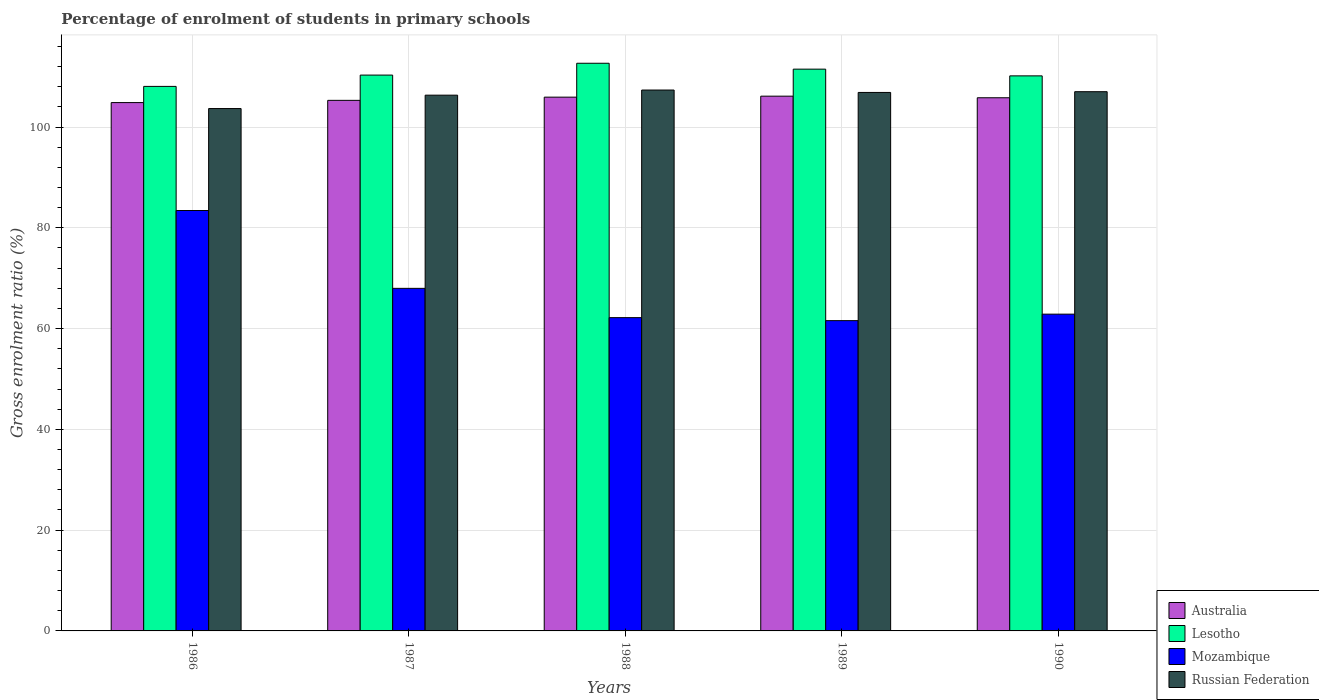How many different coloured bars are there?
Make the answer very short. 4. How many bars are there on the 2nd tick from the left?
Offer a very short reply. 4. How many bars are there on the 3rd tick from the right?
Ensure brevity in your answer.  4. What is the label of the 5th group of bars from the left?
Your answer should be compact. 1990. What is the percentage of students enrolled in primary schools in Australia in 1988?
Provide a succinct answer. 105.93. Across all years, what is the maximum percentage of students enrolled in primary schools in Mozambique?
Your answer should be very brief. 83.44. Across all years, what is the minimum percentage of students enrolled in primary schools in Australia?
Your answer should be very brief. 104.85. In which year was the percentage of students enrolled in primary schools in Lesotho maximum?
Keep it short and to the point. 1988. In which year was the percentage of students enrolled in primary schools in Russian Federation minimum?
Ensure brevity in your answer.  1986. What is the total percentage of students enrolled in primary schools in Mozambique in the graph?
Your answer should be very brief. 338.04. What is the difference between the percentage of students enrolled in primary schools in Mozambique in 1986 and that in 1987?
Your answer should be very brief. 15.45. What is the difference between the percentage of students enrolled in primary schools in Russian Federation in 1989 and the percentage of students enrolled in primary schools in Lesotho in 1990?
Your response must be concise. -3.29. What is the average percentage of students enrolled in primary schools in Russian Federation per year?
Provide a short and direct response. 106.24. In the year 1989, what is the difference between the percentage of students enrolled in primary schools in Australia and percentage of students enrolled in primary schools in Lesotho?
Provide a short and direct response. -5.36. What is the ratio of the percentage of students enrolled in primary schools in Russian Federation in 1988 to that in 1989?
Give a very brief answer. 1. Is the percentage of students enrolled in primary schools in Mozambique in 1987 less than that in 1988?
Ensure brevity in your answer.  No. Is the difference between the percentage of students enrolled in primary schools in Australia in 1988 and 1990 greater than the difference between the percentage of students enrolled in primary schools in Lesotho in 1988 and 1990?
Give a very brief answer. No. What is the difference between the highest and the second highest percentage of students enrolled in primary schools in Mozambique?
Provide a short and direct response. 15.45. What is the difference between the highest and the lowest percentage of students enrolled in primary schools in Russian Federation?
Give a very brief answer. 3.67. Is the sum of the percentage of students enrolled in primary schools in Lesotho in 1986 and 1989 greater than the maximum percentage of students enrolled in primary schools in Australia across all years?
Make the answer very short. Yes. What does the 2nd bar from the right in 1986 represents?
Your response must be concise. Mozambique. Is it the case that in every year, the sum of the percentage of students enrolled in primary schools in Lesotho and percentage of students enrolled in primary schools in Russian Federation is greater than the percentage of students enrolled in primary schools in Mozambique?
Ensure brevity in your answer.  Yes. How many bars are there?
Give a very brief answer. 20. What is the difference between two consecutive major ticks on the Y-axis?
Keep it short and to the point. 20. Are the values on the major ticks of Y-axis written in scientific E-notation?
Your response must be concise. No. Does the graph contain any zero values?
Offer a very short reply. No. What is the title of the graph?
Provide a short and direct response. Percentage of enrolment of students in primary schools. What is the Gross enrolment ratio (%) in Australia in 1986?
Give a very brief answer. 104.85. What is the Gross enrolment ratio (%) of Lesotho in 1986?
Your answer should be very brief. 108.07. What is the Gross enrolment ratio (%) of Mozambique in 1986?
Provide a succinct answer. 83.44. What is the Gross enrolment ratio (%) of Russian Federation in 1986?
Ensure brevity in your answer.  103.67. What is the Gross enrolment ratio (%) of Australia in 1987?
Offer a terse response. 105.3. What is the Gross enrolment ratio (%) of Lesotho in 1987?
Provide a succinct answer. 110.31. What is the Gross enrolment ratio (%) of Mozambique in 1987?
Offer a very short reply. 67.99. What is the Gross enrolment ratio (%) in Russian Federation in 1987?
Keep it short and to the point. 106.32. What is the Gross enrolment ratio (%) of Australia in 1988?
Keep it short and to the point. 105.93. What is the Gross enrolment ratio (%) in Lesotho in 1988?
Your answer should be very brief. 112.66. What is the Gross enrolment ratio (%) in Mozambique in 1988?
Your response must be concise. 62.18. What is the Gross enrolment ratio (%) in Russian Federation in 1988?
Give a very brief answer. 107.34. What is the Gross enrolment ratio (%) in Australia in 1989?
Keep it short and to the point. 106.13. What is the Gross enrolment ratio (%) in Lesotho in 1989?
Offer a very short reply. 111.49. What is the Gross enrolment ratio (%) in Mozambique in 1989?
Offer a terse response. 61.58. What is the Gross enrolment ratio (%) of Russian Federation in 1989?
Give a very brief answer. 106.87. What is the Gross enrolment ratio (%) in Australia in 1990?
Your response must be concise. 105.81. What is the Gross enrolment ratio (%) of Lesotho in 1990?
Provide a succinct answer. 110.15. What is the Gross enrolment ratio (%) of Mozambique in 1990?
Your answer should be compact. 62.87. What is the Gross enrolment ratio (%) of Russian Federation in 1990?
Ensure brevity in your answer.  107.01. Across all years, what is the maximum Gross enrolment ratio (%) in Australia?
Provide a succinct answer. 106.13. Across all years, what is the maximum Gross enrolment ratio (%) of Lesotho?
Make the answer very short. 112.66. Across all years, what is the maximum Gross enrolment ratio (%) in Mozambique?
Offer a terse response. 83.44. Across all years, what is the maximum Gross enrolment ratio (%) of Russian Federation?
Provide a short and direct response. 107.34. Across all years, what is the minimum Gross enrolment ratio (%) of Australia?
Keep it short and to the point. 104.85. Across all years, what is the minimum Gross enrolment ratio (%) of Lesotho?
Your response must be concise. 108.07. Across all years, what is the minimum Gross enrolment ratio (%) of Mozambique?
Provide a short and direct response. 61.58. Across all years, what is the minimum Gross enrolment ratio (%) of Russian Federation?
Ensure brevity in your answer.  103.67. What is the total Gross enrolment ratio (%) of Australia in the graph?
Offer a very short reply. 528.02. What is the total Gross enrolment ratio (%) in Lesotho in the graph?
Give a very brief answer. 552.68. What is the total Gross enrolment ratio (%) in Mozambique in the graph?
Your response must be concise. 338.04. What is the total Gross enrolment ratio (%) in Russian Federation in the graph?
Your answer should be very brief. 531.22. What is the difference between the Gross enrolment ratio (%) of Australia in 1986 and that in 1987?
Ensure brevity in your answer.  -0.44. What is the difference between the Gross enrolment ratio (%) in Lesotho in 1986 and that in 1987?
Give a very brief answer. -2.24. What is the difference between the Gross enrolment ratio (%) in Mozambique in 1986 and that in 1987?
Give a very brief answer. 15.45. What is the difference between the Gross enrolment ratio (%) of Russian Federation in 1986 and that in 1987?
Make the answer very short. -2.65. What is the difference between the Gross enrolment ratio (%) of Australia in 1986 and that in 1988?
Give a very brief answer. -1.08. What is the difference between the Gross enrolment ratio (%) in Lesotho in 1986 and that in 1988?
Make the answer very short. -4.59. What is the difference between the Gross enrolment ratio (%) of Mozambique in 1986 and that in 1988?
Keep it short and to the point. 21.26. What is the difference between the Gross enrolment ratio (%) in Russian Federation in 1986 and that in 1988?
Keep it short and to the point. -3.67. What is the difference between the Gross enrolment ratio (%) of Australia in 1986 and that in 1989?
Make the answer very short. -1.27. What is the difference between the Gross enrolment ratio (%) of Lesotho in 1986 and that in 1989?
Keep it short and to the point. -3.42. What is the difference between the Gross enrolment ratio (%) in Mozambique in 1986 and that in 1989?
Your response must be concise. 21.86. What is the difference between the Gross enrolment ratio (%) in Russian Federation in 1986 and that in 1989?
Give a very brief answer. -3.2. What is the difference between the Gross enrolment ratio (%) in Australia in 1986 and that in 1990?
Offer a very short reply. -0.96. What is the difference between the Gross enrolment ratio (%) of Lesotho in 1986 and that in 1990?
Ensure brevity in your answer.  -2.09. What is the difference between the Gross enrolment ratio (%) in Mozambique in 1986 and that in 1990?
Make the answer very short. 20.57. What is the difference between the Gross enrolment ratio (%) of Russian Federation in 1986 and that in 1990?
Your answer should be very brief. -3.34. What is the difference between the Gross enrolment ratio (%) of Australia in 1987 and that in 1988?
Your answer should be very brief. -0.64. What is the difference between the Gross enrolment ratio (%) of Lesotho in 1987 and that in 1988?
Offer a terse response. -2.35. What is the difference between the Gross enrolment ratio (%) in Mozambique in 1987 and that in 1988?
Ensure brevity in your answer.  5.81. What is the difference between the Gross enrolment ratio (%) in Russian Federation in 1987 and that in 1988?
Your answer should be compact. -1.02. What is the difference between the Gross enrolment ratio (%) in Australia in 1987 and that in 1989?
Your answer should be very brief. -0.83. What is the difference between the Gross enrolment ratio (%) of Lesotho in 1987 and that in 1989?
Provide a short and direct response. -1.18. What is the difference between the Gross enrolment ratio (%) of Mozambique in 1987 and that in 1989?
Your answer should be compact. 6.41. What is the difference between the Gross enrolment ratio (%) of Russian Federation in 1987 and that in 1989?
Your response must be concise. -0.54. What is the difference between the Gross enrolment ratio (%) in Australia in 1987 and that in 1990?
Make the answer very short. -0.51. What is the difference between the Gross enrolment ratio (%) of Lesotho in 1987 and that in 1990?
Give a very brief answer. 0.16. What is the difference between the Gross enrolment ratio (%) of Mozambique in 1987 and that in 1990?
Ensure brevity in your answer.  5.12. What is the difference between the Gross enrolment ratio (%) in Russian Federation in 1987 and that in 1990?
Provide a short and direct response. -0.69. What is the difference between the Gross enrolment ratio (%) of Australia in 1988 and that in 1989?
Your answer should be very brief. -0.19. What is the difference between the Gross enrolment ratio (%) in Lesotho in 1988 and that in 1989?
Your answer should be compact. 1.17. What is the difference between the Gross enrolment ratio (%) of Mozambique in 1988 and that in 1989?
Provide a succinct answer. 0.6. What is the difference between the Gross enrolment ratio (%) in Russian Federation in 1988 and that in 1989?
Make the answer very short. 0.48. What is the difference between the Gross enrolment ratio (%) of Australia in 1988 and that in 1990?
Give a very brief answer. 0.12. What is the difference between the Gross enrolment ratio (%) in Lesotho in 1988 and that in 1990?
Give a very brief answer. 2.5. What is the difference between the Gross enrolment ratio (%) in Mozambique in 1988 and that in 1990?
Make the answer very short. -0.69. What is the difference between the Gross enrolment ratio (%) of Russian Federation in 1988 and that in 1990?
Your response must be concise. 0.33. What is the difference between the Gross enrolment ratio (%) of Australia in 1989 and that in 1990?
Give a very brief answer. 0.32. What is the difference between the Gross enrolment ratio (%) of Lesotho in 1989 and that in 1990?
Provide a succinct answer. 1.34. What is the difference between the Gross enrolment ratio (%) of Mozambique in 1989 and that in 1990?
Make the answer very short. -1.29. What is the difference between the Gross enrolment ratio (%) in Russian Federation in 1989 and that in 1990?
Your response must be concise. -0.15. What is the difference between the Gross enrolment ratio (%) in Australia in 1986 and the Gross enrolment ratio (%) in Lesotho in 1987?
Keep it short and to the point. -5.46. What is the difference between the Gross enrolment ratio (%) of Australia in 1986 and the Gross enrolment ratio (%) of Mozambique in 1987?
Offer a terse response. 36.87. What is the difference between the Gross enrolment ratio (%) of Australia in 1986 and the Gross enrolment ratio (%) of Russian Federation in 1987?
Provide a succinct answer. -1.47. What is the difference between the Gross enrolment ratio (%) in Lesotho in 1986 and the Gross enrolment ratio (%) in Mozambique in 1987?
Your response must be concise. 40.08. What is the difference between the Gross enrolment ratio (%) of Lesotho in 1986 and the Gross enrolment ratio (%) of Russian Federation in 1987?
Keep it short and to the point. 1.74. What is the difference between the Gross enrolment ratio (%) in Mozambique in 1986 and the Gross enrolment ratio (%) in Russian Federation in 1987?
Ensure brevity in your answer.  -22.89. What is the difference between the Gross enrolment ratio (%) in Australia in 1986 and the Gross enrolment ratio (%) in Lesotho in 1988?
Ensure brevity in your answer.  -7.8. What is the difference between the Gross enrolment ratio (%) in Australia in 1986 and the Gross enrolment ratio (%) in Mozambique in 1988?
Keep it short and to the point. 42.68. What is the difference between the Gross enrolment ratio (%) of Australia in 1986 and the Gross enrolment ratio (%) of Russian Federation in 1988?
Your answer should be compact. -2.49. What is the difference between the Gross enrolment ratio (%) in Lesotho in 1986 and the Gross enrolment ratio (%) in Mozambique in 1988?
Provide a short and direct response. 45.89. What is the difference between the Gross enrolment ratio (%) of Lesotho in 1986 and the Gross enrolment ratio (%) of Russian Federation in 1988?
Ensure brevity in your answer.  0.72. What is the difference between the Gross enrolment ratio (%) in Mozambique in 1986 and the Gross enrolment ratio (%) in Russian Federation in 1988?
Ensure brevity in your answer.  -23.91. What is the difference between the Gross enrolment ratio (%) in Australia in 1986 and the Gross enrolment ratio (%) in Lesotho in 1989?
Your response must be concise. -6.64. What is the difference between the Gross enrolment ratio (%) of Australia in 1986 and the Gross enrolment ratio (%) of Mozambique in 1989?
Offer a very short reply. 43.28. What is the difference between the Gross enrolment ratio (%) in Australia in 1986 and the Gross enrolment ratio (%) in Russian Federation in 1989?
Offer a terse response. -2.01. What is the difference between the Gross enrolment ratio (%) in Lesotho in 1986 and the Gross enrolment ratio (%) in Mozambique in 1989?
Give a very brief answer. 46.49. What is the difference between the Gross enrolment ratio (%) in Lesotho in 1986 and the Gross enrolment ratio (%) in Russian Federation in 1989?
Offer a very short reply. 1.2. What is the difference between the Gross enrolment ratio (%) in Mozambique in 1986 and the Gross enrolment ratio (%) in Russian Federation in 1989?
Your response must be concise. -23.43. What is the difference between the Gross enrolment ratio (%) of Australia in 1986 and the Gross enrolment ratio (%) of Lesotho in 1990?
Keep it short and to the point. -5.3. What is the difference between the Gross enrolment ratio (%) in Australia in 1986 and the Gross enrolment ratio (%) in Mozambique in 1990?
Your response must be concise. 41.99. What is the difference between the Gross enrolment ratio (%) of Australia in 1986 and the Gross enrolment ratio (%) of Russian Federation in 1990?
Ensure brevity in your answer.  -2.16. What is the difference between the Gross enrolment ratio (%) of Lesotho in 1986 and the Gross enrolment ratio (%) of Mozambique in 1990?
Your response must be concise. 45.2. What is the difference between the Gross enrolment ratio (%) of Lesotho in 1986 and the Gross enrolment ratio (%) of Russian Federation in 1990?
Your answer should be very brief. 1.05. What is the difference between the Gross enrolment ratio (%) in Mozambique in 1986 and the Gross enrolment ratio (%) in Russian Federation in 1990?
Ensure brevity in your answer.  -23.58. What is the difference between the Gross enrolment ratio (%) of Australia in 1987 and the Gross enrolment ratio (%) of Lesotho in 1988?
Provide a short and direct response. -7.36. What is the difference between the Gross enrolment ratio (%) of Australia in 1987 and the Gross enrolment ratio (%) of Mozambique in 1988?
Offer a terse response. 43.12. What is the difference between the Gross enrolment ratio (%) in Australia in 1987 and the Gross enrolment ratio (%) in Russian Federation in 1988?
Keep it short and to the point. -2.05. What is the difference between the Gross enrolment ratio (%) in Lesotho in 1987 and the Gross enrolment ratio (%) in Mozambique in 1988?
Provide a succinct answer. 48.13. What is the difference between the Gross enrolment ratio (%) of Lesotho in 1987 and the Gross enrolment ratio (%) of Russian Federation in 1988?
Your answer should be very brief. 2.96. What is the difference between the Gross enrolment ratio (%) of Mozambique in 1987 and the Gross enrolment ratio (%) of Russian Federation in 1988?
Offer a terse response. -39.36. What is the difference between the Gross enrolment ratio (%) in Australia in 1987 and the Gross enrolment ratio (%) in Lesotho in 1989?
Provide a short and direct response. -6.19. What is the difference between the Gross enrolment ratio (%) of Australia in 1987 and the Gross enrolment ratio (%) of Mozambique in 1989?
Your answer should be compact. 43.72. What is the difference between the Gross enrolment ratio (%) in Australia in 1987 and the Gross enrolment ratio (%) in Russian Federation in 1989?
Offer a terse response. -1.57. What is the difference between the Gross enrolment ratio (%) in Lesotho in 1987 and the Gross enrolment ratio (%) in Mozambique in 1989?
Provide a short and direct response. 48.73. What is the difference between the Gross enrolment ratio (%) of Lesotho in 1987 and the Gross enrolment ratio (%) of Russian Federation in 1989?
Keep it short and to the point. 3.44. What is the difference between the Gross enrolment ratio (%) in Mozambique in 1987 and the Gross enrolment ratio (%) in Russian Federation in 1989?
Your answer should be compact. -38.88. What is the difference between the Gross enrolment ratio (%) of Australia in 1987 and the Gross enrolment ratio (%) of Lesotho in 1990?
Provide a succinct answer. -4.86. What is the difference between the Gross enrolment ratio (%) in Australia in 1987 and the Gross enrolment ratio (%) in Mozambique in 1990?
Your answer should be compact. 42.43. What is the difference between the Gross enrolment ratio (%) of Australia in 1987 and the Gross enrolment ratio (%) of Russian Federation in 1990?
Offer a terse response. -1.72. What is the difference between the Gross enrolment ratio (%) in Lesotho in 1987 and the Gross enrolment ratio (%) in Mozambique in 1990?
Offer a very short reply. 47.44. What is the difference between the Gross enrolment ratio (%) of Lesotho in 1987 and the Gross enrolment ratio (%) of Russian Federation in 1990?
Give a very brief answer. 3.3. What is the difference between the Gross enrolment ratio (%) in Mozambique in 1987 and the Gross enrolment ratio (%) in Russian Federation in 1990?
Ensure brevity in your answer.  -39.03. What is the difference between the Gross enrolment ratio (%) of Australia in 1988 and the Gross enrolment ratio (%) of Lesotho in 1989?
Give a very brief answer. -5.56. What is the difference between the Gross enrolment ratio (%) in Australia in 1988 and the Gross enrolment ratio (%) in Mozambique in 1989?
Offer a terse response. 44.35. What is the difference between the Gross enrolment ratio (%) in Australia in 1988 and the Gross enrolment ratio (%) in Russian Federation in 1989?
Offer a very short reply. -0.93. What is the difference between the Gross enrolment ratio (%) in Lesotho in 1988 and the Gross enrolment ratio (%) in Mozambique in 1989?
Provide a succinct answer. 51.08. What is the difference between the Gross enrolment ratio (%) in Lesotho in 1988 and the Gross enrolment ratio (%) in Russian Federation in 1989?
Your answer should be compact. 5.79. What is the difference between the Gross enrolment ratio (%) of Mozambique in 1988 and the Gross enrolment ratio (%) of Russian Federation in 1989?
Your answer should be very brief. -44.69. What is the difference between the Gross enrolment ratio (%) in Australia in 1988 and the Gross enrolment ratio (%) in Lesotho in 1990?
Make the answer very short. -4.22. What is the difference between the Gross enrolment ratio (%) in Australia in 1988 and the Gross enrolment ratio (%) in Mozambique in 1990?
Ensure brevity in your answer.  43.07. What is the difference between the Gross enrolment ratio (%) in Australia in 1988 and the Gross enrolment ratio (%) in Russian Federation in 1990?
Your answer should be compact. -1.08. What is the difference between the Gross enrolment ratio (%) of Lesotho in 1988 and the Gross enrolment ratio (%) of Mozambique in 1990?
Provide a succinct answer. 49.79. What is the difference between the Gross enrolment ratio (%) of Lesotho in 1988 and the Gross enrolment ratio (%) of Russian Federation in 1990?
Provide a short and direct response. 5.64. What is the difference between the Gross enrolment ratio (%) in Mozambique in 1988 and the Gross enrolment ratio (%) in Russian Federation in 1990?
Your answer should be very brief. -44.84. What is the difference between the Gross enrolment ratio (%) in Australia in 1989 and the Gross enrolment ratio (%) in Lesotho in 1990?
Provide a short and direct response. -4.03. What is the difference between the Gross enrolment ratio (%) of Australia in 1989 and the Gross enrolment ratio (%) of Mozambique in 1990?
Your response must be concise. 43.26. What is the difference between the Gross enrolment ratio (%) in Australia in 1989 and the Gross enrolment ratio (%) in Russian Federation in 1990?
Provide a short and direct response. -0.89. What is the difference between the Gross enrolment ratio (%) of Lesotho in 1989 and the Gross enrolment ratio (%) of Mozambique in 1990?
Ensure brevity in your answer.  48.62. What is the difference between the Gross enrolment ratio (%) of Lesotho in 1989 and the Gross enrolment ratio (%) of Russian Federation in 1990?
Your answer should be compact. 4.48. What is the difference between the Gross enrolment ratio (%) in Mozambique in 1989 and the Gross enrolment ratio (%) in Russian Federation in 1990?
Your response must be concise. -45.44. What is the average Gross enrolment ratio (%) of Australia per year?
Your answer should be very brief. 105.6. What is the average Gross enrolment ratio (%) in Lesotho per year?
Make the answer very short. 110.54. What is the average Gross enrolment ratio (%) in Mozambique per year?
Keep it short and to the point. 67.61. What is the average Gross enrolment ratio (%) of Russian Federation per year?
Ensure brevity in your answer.  106.24. In the year 1986, what is the difference between the Gross enrolment ratio (%) in Australia and Gross enrolment ratio (%) in Lesotho?
Provide a succinct answer. -3.21. In the year 1986, what is the difference between the Gross enrolment ratio (%) in Australia and Gross enrolment ratio (%) in Mozambique?
Your answer should be compact. 21.42. In the year 1986, what is the difference between the Gross enrolment ratio (%) of Australia and Gross enrolment ratio (%) of Russian Federation?
Your response must be concise. 1.18. In the year 1986, what is the difference between the Gross enrolment ratio (%) of Lesotho and Gross enrolment ratio (%) of Mozambique?
Give a very brief answer. 24.63. In the year 1986, what is the difference between the Gross enrolment ratio (%) of Lesotho and Gross enrolment ratio (%) of Russian Federation?
Offer a terse response. 4.4. In the year 1986, what is the difference between the Gross enrolment ratio (%) in Mozambique and Gross enrolment ratio (%) in Russian Federation?
Give a very brief answer. -20.23. In the year 1987, what is the difference between the Gross enrolment ratio (%) of Australia and Gross enrolment ratio (%) of Lesotho?
Provide a short and direct response. -5.01. In the year 1987, what is the difference between the Gross enrolment ratio (%) in Australia and Gross enrolment ratio (%) in Mozambique?
Your answer should be very brief. 37.31. In the year 1987, what is the difference between the Gross enrolment ratio (%) of Australia and Gross enrolment ratio (%) of Russian Federation?
Make the answer very short. -1.03. In the year 1987, what is the difference between the Gross enrolment ratio (%) in Lesotho and Gross enrolment ratio (%) in Mozambique?
Offer a very short reply. 42.32. In the year 1987, what is the difference between the Gross enrolment ratio (%) in Lesotho and Gross enrolment ratio (%) in Russian Federation?
Provide a short and direct response. 3.98. In the year 1987, what is the difference between the Gross enrolment ratio (%) in Mozambique and Gross enrolment ratio (%) in Russian Federation?
Provide a succinct answer. -38.34. In the year 1988, what is the difference between the Gross enrolment ratio (%) of Australia and Gross enrolment ratio (%) of Lesotho?
Provide a short and direct response. -6.72. In the year 1988, what is the difference between the Gross enrolment ratio (%) of Australia and Gross enrolment ratio (%) of Mozambique?
Ensure brevity in your answer.  43.76. In the year 1988, what is the difference between the Gross enrolment ratio (%) in Australia and Gross enrolment ratio (%) in Russian Federation?
Make the answer very short. -1.41. In the year 1988, what is the difference between the Gross enrolment ratio (%) of Lesotho and Gross enrolment ratio (%) of Mozambique?
Your response must be concise. 50.48. In the year 1988, what is the difference between the Gross enrolment ratio (%) in Lesotho and Gross enrolment ratio (%) in Russian Federation?
Ensure brevity in your answer.  5.31. In the year 1988, what is the difference between the Gross enrolment ratio (%) in Mozambique and Gross enrolment ratio (%) in Russian Federation?
Ensure brevity in your answer.  -45.17. In the year 1989, what is the difference between the Gross enrolment ratio (%) of Australia and Gross enrolment ratio (%) of Lesotho?
Your response must be concise. -5.36. In the year 1989, what is the difference between the Gross enrolment ratio (%) in Australia and Gross enrolment ratio (%) in Mozambique?
Offer a terse response. 44.55. In the year 1989, what is the difference between the Gross enrolment ratio (%) of Australia and Gross enrolment ratio (%) of Russian Federation?
Give a very brief answer. -0.74. In the year 1989, what is the difference between the Gross enrolment ratio (%) of Lesotho and Gross enrolment ratio (%) of Mozambique?
Keep it short and to the point. 49.91. In the year 1989, what is the difference between the Gross enrolment ratio (%) of Lesotho and Gross enrolment ratio (%) of Russian Federation?
Offer a very short reply. 4.62. In the year 1989, what is the difference between the Gross enrolment ratio (%) of Mozambique and Gross enrolment ratio (%) of Russian Federation?
Provide a short and direct response. -45.29. In the year 1990, what is the difference between the Gross enrolment ratio (%) in Australia and Gross enrolment ratio (%) in Lesotho?
Your response must be concise. -4.34. In the year 1990, what is the difference between the Gross enrolment ratio (%) of Australia and Gross enrolment ratio (%) of Mozambique?
Keep it short and to the point. 42.94. In the year 1990, what is the difference between the Gross enrolment ratio (%) in Australia and Gross enrolment ratio (%) in Russian Federation?
Give a very brief answer. -1.2. In the year 1990, what is the difference between the Gross enrolment ratio (%) in Lesotho and Gross enrolment ratio (%) in Mozambique?
Keep it short and to the point. 47.29. In the year 1990, what is the difference between the Gross enrolment ratio (%) in Lesotho and Gross enrolment ratio (%) in Russian Federation?
Offer a very short reply. 3.14. In the year 1990, what is the difference between the Gross enrolment ratio (%) in Mozambique and Gross enrolment ratio (%) in Russian Federation?
Give a very brief answer. -44.15. What is the ratio of the Gross enrolment ratio (%) of Lesotho in 1986 to that in 1987?
Ensure brevity in your answer.  0.98. What is the ratio of the Gross enrolment ratio (%) in Mozambique in 1986 to that in 1987?
Offer a very short reply. 1.23. What is the ratio of the Gross enrolment ratio (%) in Russian Federation in 1986 to that in 1987?
Your answer should be very brief. 0.97. What is the ratio of the Gross enrolment ratio (%) of Lesotho in 1986 to that in 1988?
Your answer should be compact. 0.96. What is the ratio of the Gross enrolment ratio (%) of Mozambique in 1986 to that in 1988?
Make the answer very short. 1.34. What is the ratio of the Gross enrolment ratio (%) of Russian Federation in 1986 to that in 1988?
Give a very brief answer. 0.97. What is the ratio of the Gross enrolment ratio (%) in Australia in 1986 to that in 1989?
Your answer should be compact. 0.99. What is the ratio of the Gross enrolment ratio (%) of Lesotho in 1986 to that in 1989?
Ensure brevity in your answer.  0.97. What is the ratio of the Gross enrolment ratio (%) in Mozambique in 1986 to that in 1989?
Offer a terse response. 1.35. What is the ratio of the Gross enrolment ratio (%) of Russian Federation in 1986 to that in 1989?
Your answer should be compact. 0.97. What is the ratio of the Gross enrolment ratio (%) of Australia in 1986 to that in 1990?
Provide a short and direct response. 0.99. What is the ratio of the Gross enrolment ratio (%) of Mozambique in 1986 to that in 1990?
Your answer should be very brief. 1.33. What is the ratio of the Gross enrolment ratio (%) in Russian Federation in 1986 to that in 1990?
Give a very brief answer. 0.97. What is the ratio of the Gross enrolment ratio (%) in Australia in 1987 to that in 1988?
Provide a short and direct response. 0.99. What is the ratio of the Gross enrolment ratio (%) in Lesotho in 1987 to that in 1988?
Offer a terse response. 0.98. What is the ratio of the Gross enrolment ratio (%) of Mozambique in 1987 to that in 1988?
Your response must be concise. 1.09. What is the ratio of the Gross enrolment ratio (%) of Russian Federation in 1987 to that in 1988?
Give a very brief answer. 0.99. What is the ratio of the Gross enrolment ratio (%) in Australia in 1987 to that in 1989?
Provide a short and direct response. 0.99. What is the ratio of the Gross enrolment ratio (%) of Lesotho in 1987 to that in 1989?
Keep it short and to the point. 0.99. What is the ratio of the Gross enrolment ratio (%) of Mozambique in 1987 to that in 1989?
Your answer should be very brief. 1.1. What is the ratio of the Gross enrolment ratio (%) of Lesotho in 1987 to that in 1990?
Provide a succinct answer. 1. What is the ratio of the Gross enrolment ratio (%) in Mozambique in 1987 to that in 1990?
Give a very brief answer. 1.08. What is the ratio of the Gross enrolment ratio (%) of Australia in 1988 to that in 1989?
Your response must be concise. 1. What is the ratio of the Gross enrolment ratio (%) in Lesotho in 1988 to that in 1989?
Your answer should be very brief. 1.01. What is the ratio of the Gross enrolment ratio (%) of Mozambique in 1988 to that in 1989?
Provide a succinct answer. 1.01. What is the ratio of the Gross enrolment ratio (%) in Lesotho in 1988 to that in 1990?
Your answer should be compact. 1.02. What is the ratio of the Gross enrolment ratio (%) of Mozambique in 1988 to that in 1990?
Offer a terse response. 0.99. What is the ratio of the Gross enrolment ratio (%) of Russian Federation in 1988 to that in 1990?
Your answer should be very brief. 1. What is the ratio of the Gross enrolment ratio (%) of Lesotho in 1989 to that in 1990?
Provide a short and direct response. 1.01. What is the ratio of the Gross enrolment ratio (%) in Mozambique in 1989 to that in 1990?
Your answer should be compact. 0.98. What is the ratio of the Gross enrolment ratio (%) in Russian Federation in 1989 to that in 1990?
Ensure brevity in your answer.  1. What is the difference between the highest and the second highest Gross enrolment ratio (%) of Australia?
Your answer should be very brief. 0.19. What is the difference between the highest and the second highest Gross enrolment ratio (%) of Lesotho?
Ensure brevity in your answer.  1.17. What is the difference between the highest and the second highest Gross enrolment ratio (%) of Mozambique?
Make the answer very short. 15.45. What is the difference between the highest and the second highest Gross enrolment ratio (%) of Russian Federation?
Your answer should be very brief. 0.33. What is the difference between the highest and the lowest Gross enrolment ratio (%) of Australia?
Offer a very short reply. 1.27. What is the difference between the highest and the lowest Gross enrolment ratio (%) of Lesotho?
Keep it short and to the point. 4.59. What is the difference between the highest and the lowest Gross enrolment ratio (%) of Mozambique?
Your answer should be very brief. 21.86. What is the difference between the highest and the lowest Gross enrolment ratio (%) of Russian Federation?
Provide a succinct answer. 3.67. 